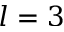Convert formula to latex. <formula><loc_0><loc_0><loc_500><loc_500>l = 3</formula> 